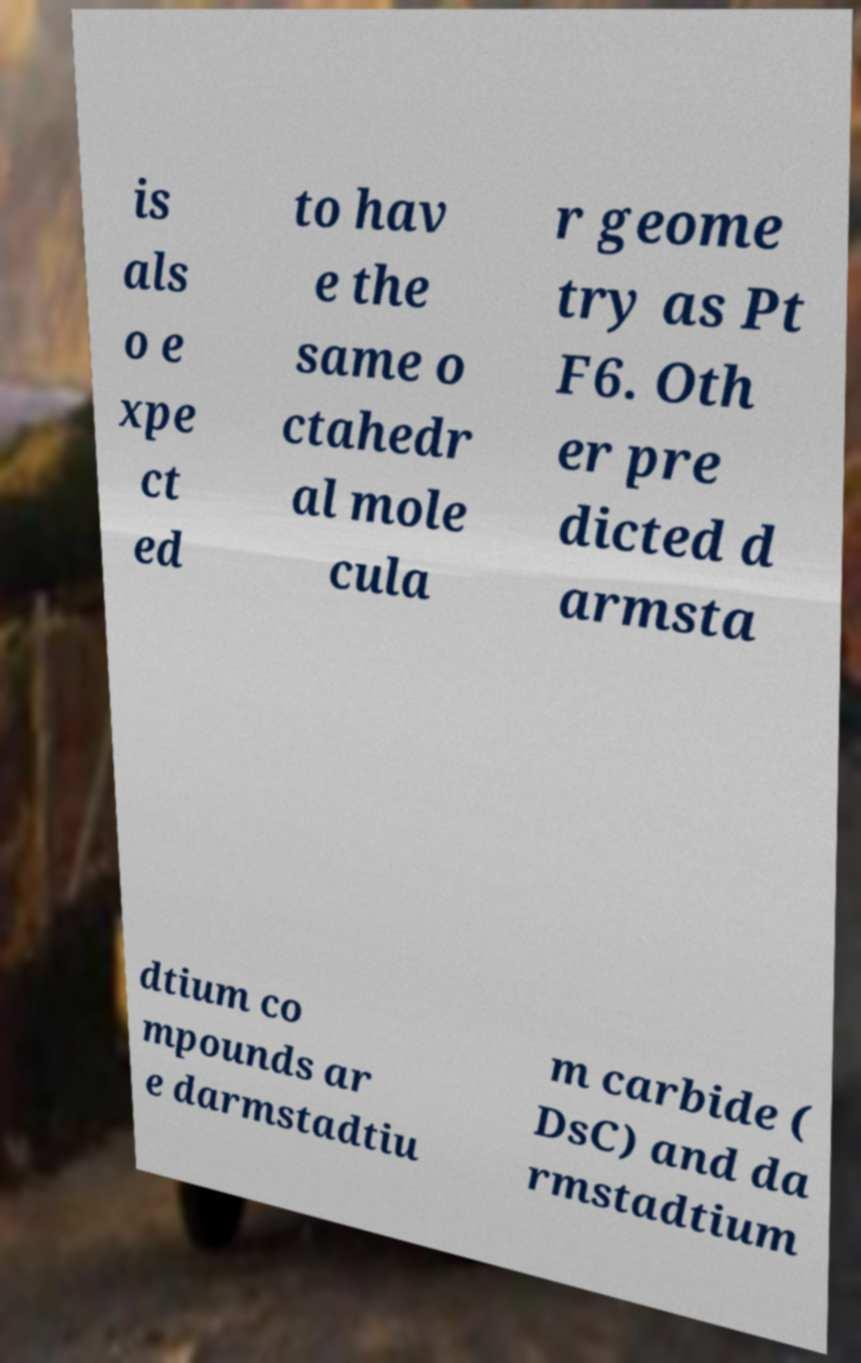Can you accurately transcribe the text from the provided image for me? is als o e xpe ct ed to hav e the same o ctahedr al mole cula r geome try as Pt F6. Oth er pre dicted d armsta dtium co mpounds ar e darmstadtiu m carbide ( DsC) and da rmstadtium 